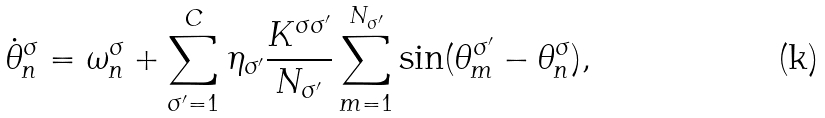<formula> <loc_0><loc_0><loc_500><loc_500>\dot { \theta } _ { n } ^ { \sigma } = \omega _ { n } ^ { \sigma } + \sum _ { \sigma ^ { \prime } = 1 } ^ { C } \eta _ { \sigma ^ { \prime } } \frac { K ^ { \sigma \sigma ^ { \prime } } } { N _ { \sigma ^ { \prime } } } \sum _ { m = 1 } ^ { N _ { \sigma ^ { \prime } } } \sin ( \theta _ { m } ^ { \sigma ^ { \prime } } - \theta _ { n } ^ { \sigma } ) ,</formula> 